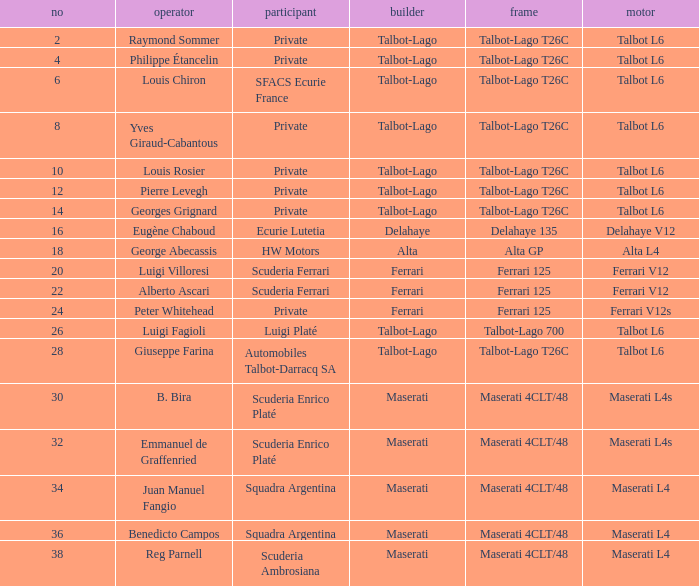Name the constructor for number 10 Talbot-Lago. 